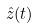<formula> <loc_0><loc_0><loc_500><loc_500>\hat { z } ( t )</formula> 